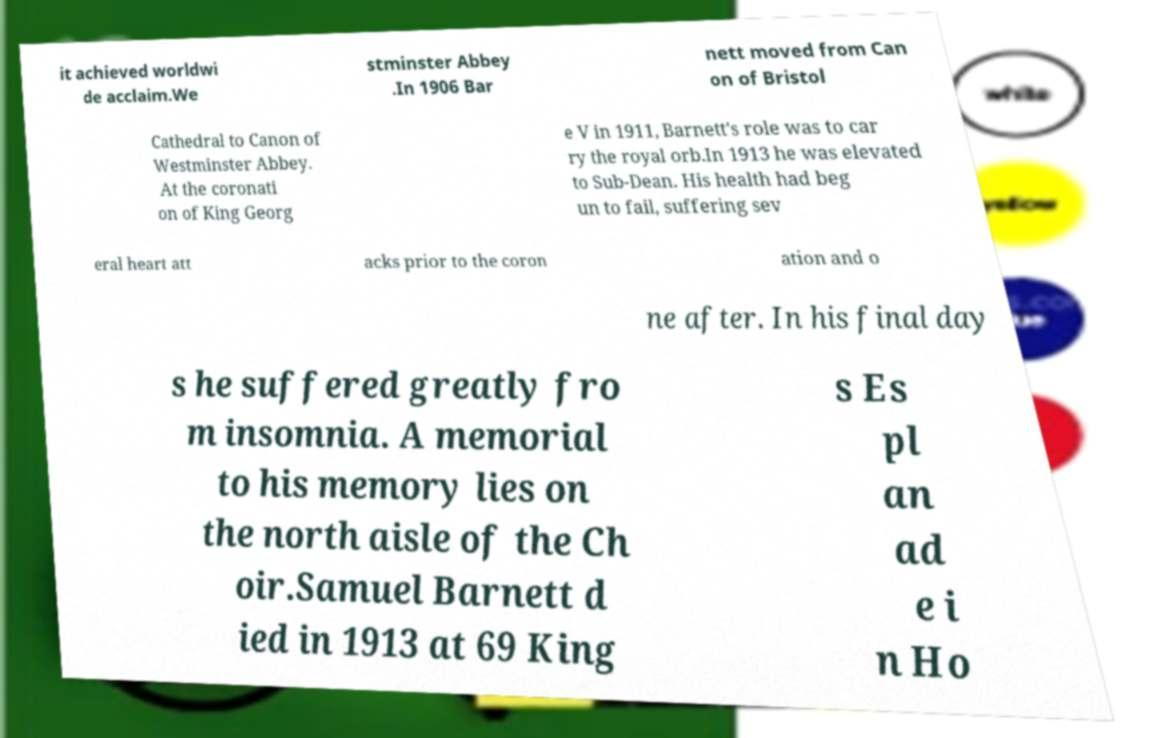Can you accurately transcribe the text from the provided image for me? it achieved worldwi de acclaim.We stminster Abbey .In 1906 Bar nett moved from Can on of Bristol Cathedral to Canon of Westminster Abbey. At the coronati on of King Georg e V in 1911, Barnett's role was to car ry the royal orb.In 1913 he was elevated to Sub-Dean. His health had beg un to fail, suffering sev eral heart att acks prior to the coron ation and o ne after. In his final day s he suffered greatly fro m insomnia. A memorial to his memory lies on the north aisle of the Ch oir.Samuel Barnett d ied in 1913 at 69 King s Es pl an ad e i n Ho 